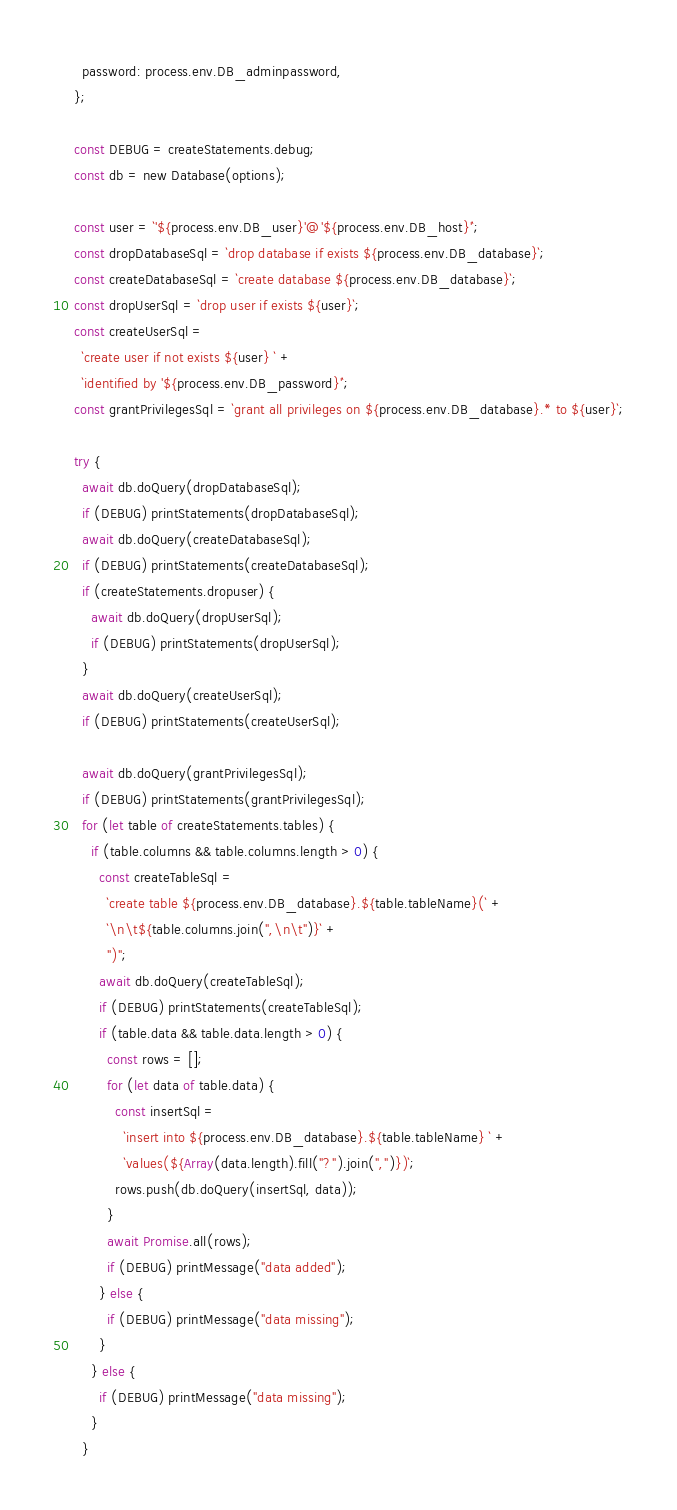<code> <loc_0><loc_0><loc_500><loc_500><_JavaScript_>    password: process.env.DB_adminpassword,
  };

  const DEBUG = createStatements.debug;
  const db = new Database(options);

  const user = `'${process.env.DB_user}'@'${process.env.DB_host}'`;
  const dropDatabaseSql = `drop database if exists ${process.env.DB_database}`;
  const createDatabaseSql = `create database ${process.env.DB_database}`;
  const dropUserSql = `drop user if exists ${user}`;
  const createUserSql =
    `create user if not exists ${user} ` +
    `identified by '${process.env.DB_password}'`;
  const grantPrivilegesSql = `grant all privileges on ${process.env.DB_database}.* to ${user}`;

  try {
    await db.doQuery(dropDatabaseSql);
    if (DEBUG) printStatements(dropDatabaseSql);
    await db.doQuery(createDatabaseSql);
    if (DEBUG) printStatements(createDatabaseSql);
    if (createStatements.dropuser) {
      await db.doQuery(dropUserSql);
      if (DEBUG) printStatements(dropUserSql);
    }
    await db.doQuery(createUserSql);
    if (DEBUG) printStatements(createUserSql);

    await db.doQuery(grantPrivilegesSql);
    if (DEBUG) printStatements(grantPrivilegesSql);
    for (let table of createStatements.tables) {
      if (table.columns && table.columns.length > 0) {
        const createTableSql =
          `create table ${process.env.DB_database}.${table.tableName}(` +
          `\n\t${table.columns.join(",\n\t")}` +
          ")";
        await db.doQuery(createTableSql);
        if (DEBUG) printStatements(createTableSql);
        if (table.data && table.data.length > 0) {
          const rows = [];
          for (let data of table.data) {
            const insertSql =
              `insert into ${process.env.DB_database}.${table.tableName} ` +
              `values(${Array(data.length).fill("?").join(",")})`;
            rows.push(db.doQuery(insertSql, data));
          }
          await Promise.all(rows);
          if (DEBUG) printMessage("data added");
        } else {
          if (DEBUG) printMessage("data missing");
        }
      } else {
        if (DEBUG) printMessage("data missing");
      }
    }</code> 